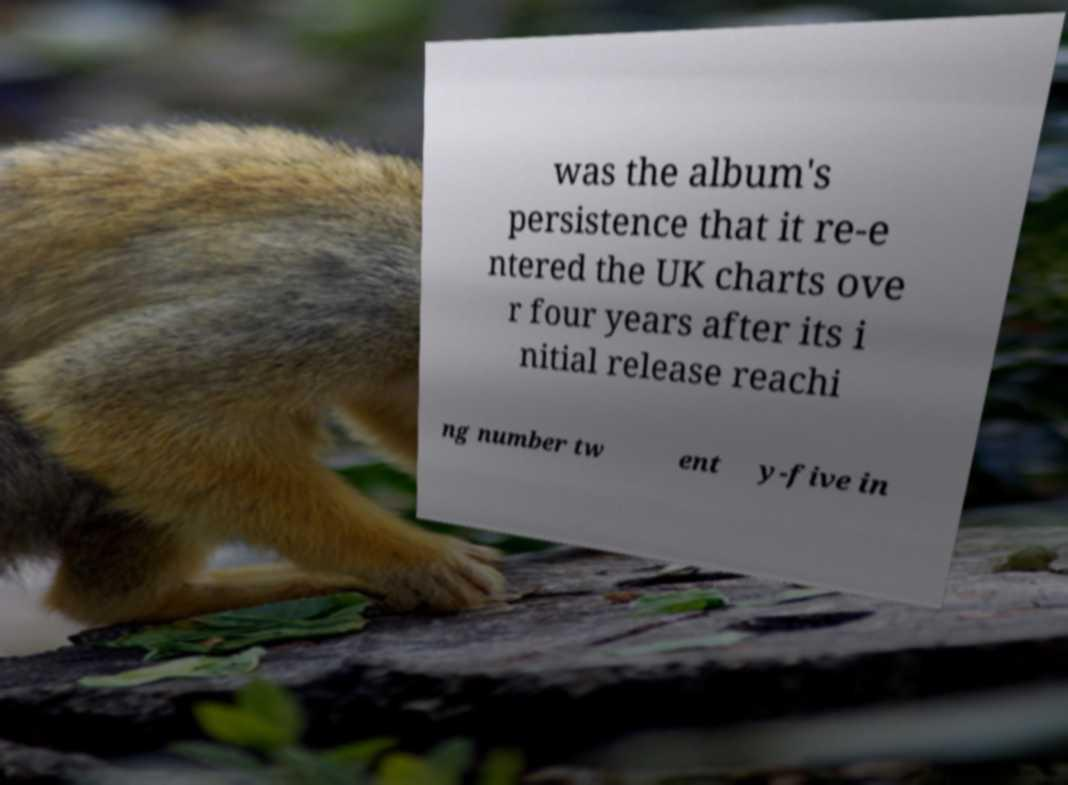I need the written content from this picture converted into text. Can you do that? was the album's persistence that it re-e ntered the UK charts ove r four years after its i nitial release reachi ng number tw ent y-five in 